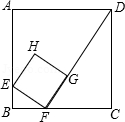How would the position and size of square EFGH change if BF were increased to 3.0? Increasing BF to 3.0 would alter the configuration of square EFGH significantly. Since the length of BF partially determines the positioning of point F along side BC, a longer BF shifts F closer to C. Simultaneously, it necessitates reconfiguring other points to uphold square properties, which may result in EFGH being smaller or repositioned more towards segment DC of square ABCD. 